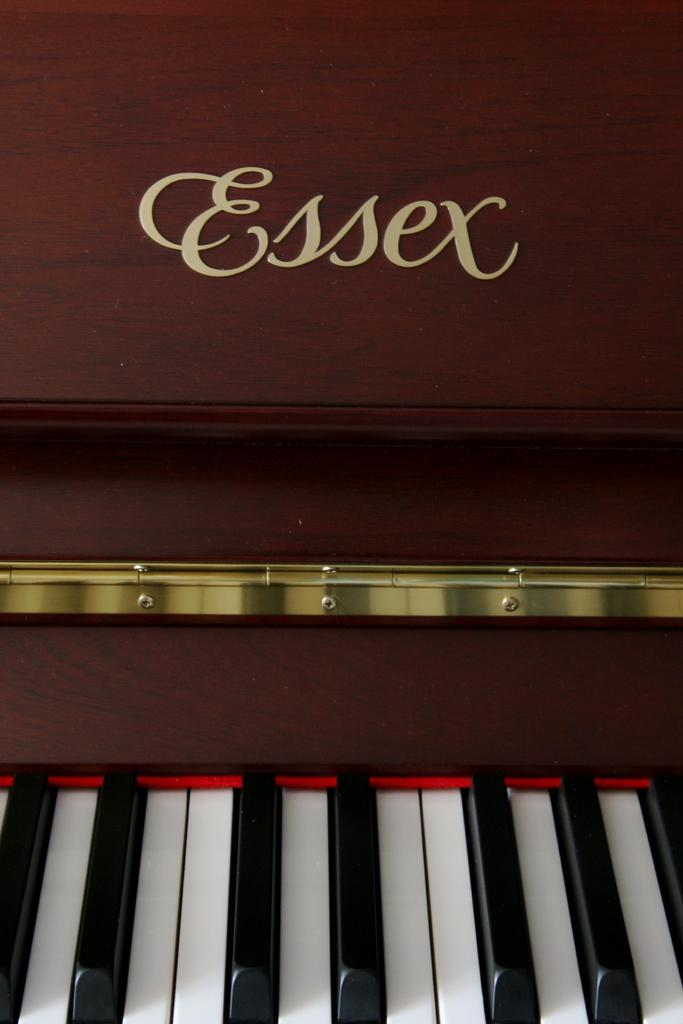What musical instrument is present in the image? There is a piano in the image. What distinguishing feature can be observed on the piano's keys? The piano has white and black keys. What else is featured in the image besides the piano? There is text visible in the image. Can you tell me how many feet the actor is standing on in the image? There is no actor or feet present in the image; it features a piano with text. What type of legal advice is the lawyer providing in the image? There is no lawyer or legal advice present in the image; it features a piano with text. 